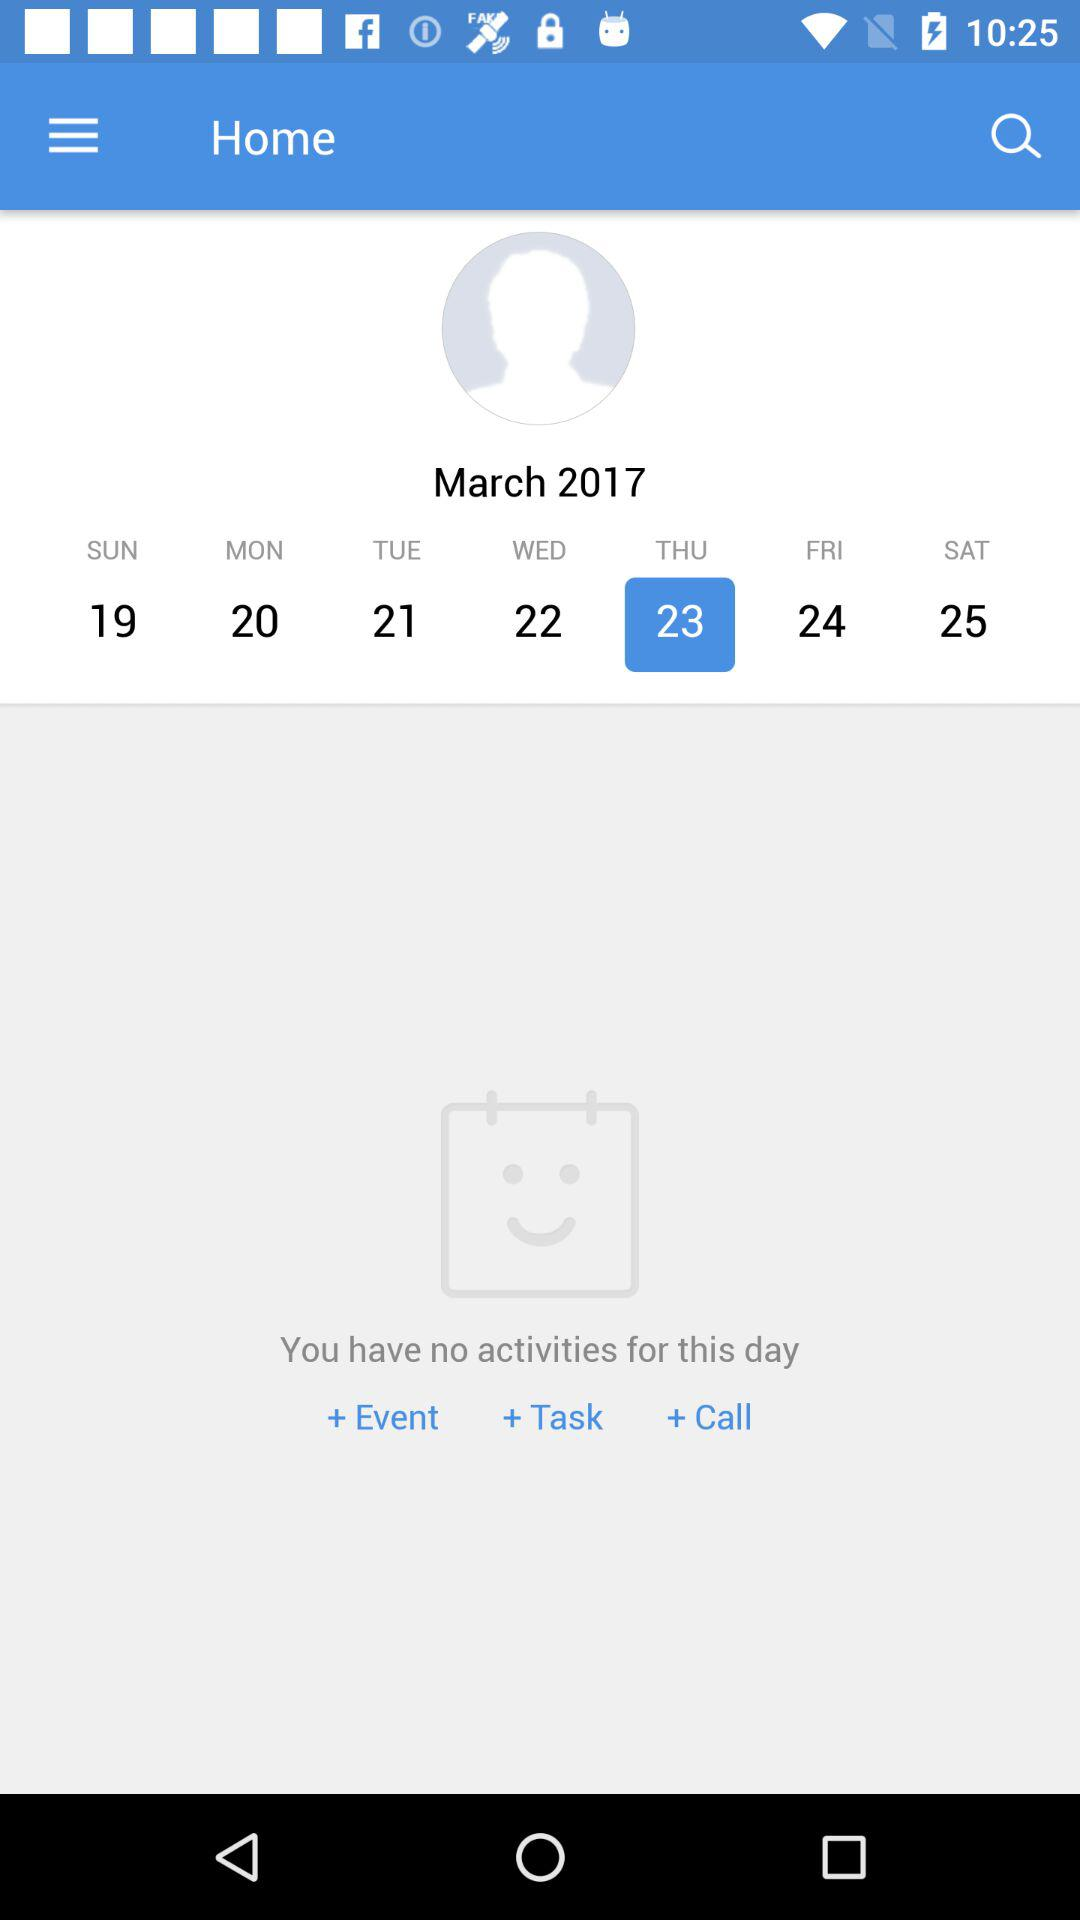Which date is selected? The selected date is Thursday, March 23, 2017. 